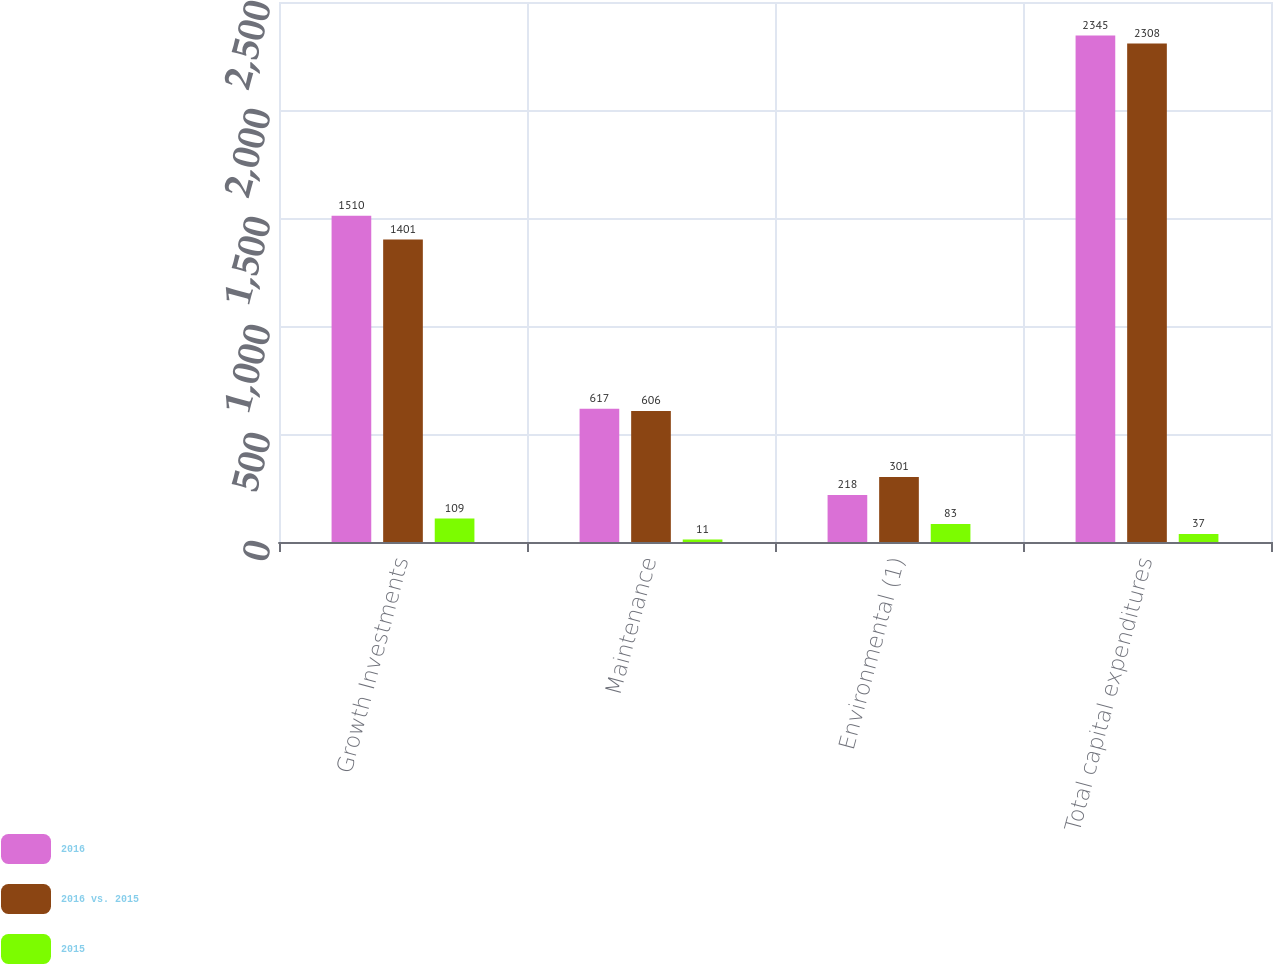<chart> <loc_0><loc_0><loc_500><loc_500><stacked_bar_chart><ecel><fcel>Growth Investments<fcel>Maintenance<fcel>Environmental (1)<fcel>Total capital expenditures<nl><fcel>2016<fcel>1510<fcel>617<fcel>218<fcel>2345<nl><fcel>2016 vs. 2015<fcel>1401<fcel>606<fcel>301<fcel>2308<nl><fcel>2015<fcel>109<fcel>11<fcel>83<fcel>37<nl></chart> 